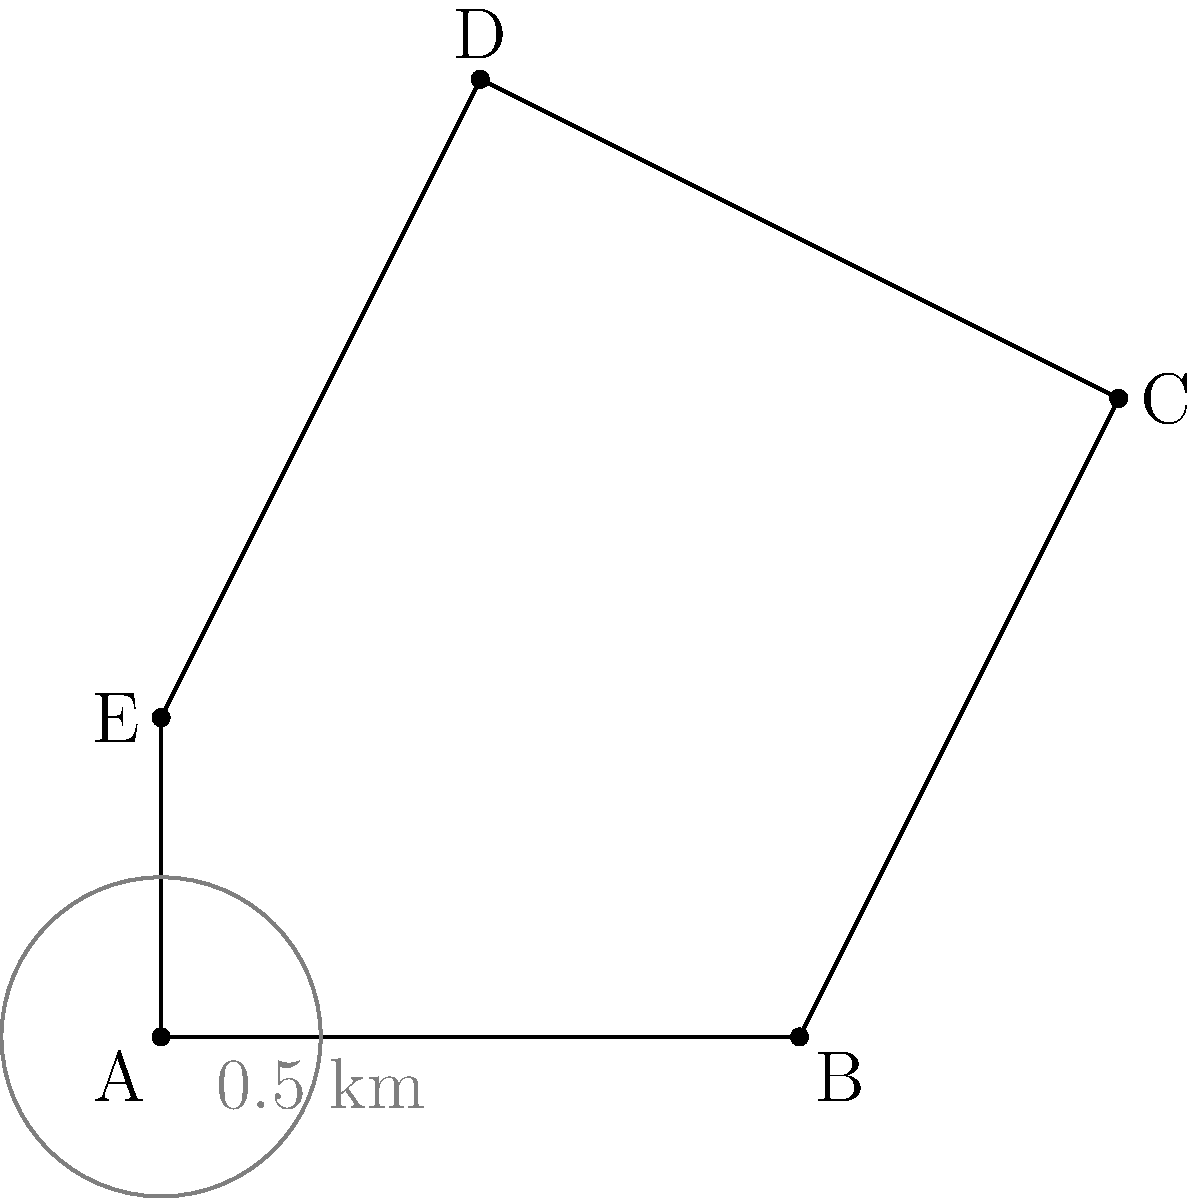As a park ranger at Stark Parks, you need to calculate the area of a new trail map with irregular boundaries. The trail map is represented by the polygon ABCDE shown above, where each unit on the grid represents 1 km. Using the trapezoidal method, what is the approximate area of the trail map in square kilometers? To calculate the area of the irregular polygon using the trapezoidal method, we'll follow these steps:

1) Divide the polygon into three trapezoids: ABCE, BCD, and CDE.

2) Calculate the area of each trapezoid using the formula: $A = \frac{1}{2}(b_1 + b_2)h$, where $b_1$ and $b_2$ are the parallel sides and $h$ is the height.

3) For trapezoid ABCE:
   $b_1 = 2$ km, $b_2 = 1$ km, $h = 1$ km
   $A_{ABCE} = \frac{1}{2}(2 + 1) \cdot 1 = 1.5$ sq km

4) For trapezoid BCD:
   $b_1 = 1$ km, $b_2 = 2$ km, $h = 2$ km
   $A_{BCD} = \frac{1}{2}(1 + 2) \cdot 2 = 3$ sq km

5) For trapezoid CDE:
   $b_1 = 2$ km, $b_2 = 1$ km, $h = 1$ km
   $A_{CDE} = \frac{1}{2}(2 + 1) \cdot 1 = 1.5$ sq km

6) Sum up the areas of all trapezoids:
   $A_{total} = A_{ABCE} + A_{BCD} + A_{CDE} = 1.5 + 3 + 1.5 = 6$ sq km

Therefore, the approximate area of the trail map is 6 square kilometers.
Answer: 6 sq km 